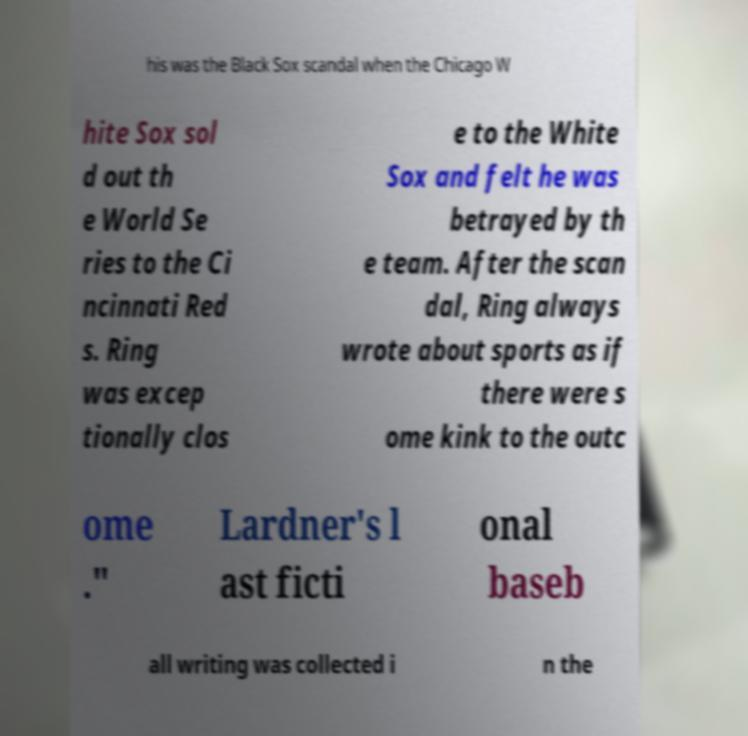There's text embedded in this image that I need extracted. Can you transcribe it verbatim? his was the Black Sox scandal when the Chicago W hite Sox sol d out th e World Se ries to the Ci ncinnati Red s. Ring was excep tionally clos e to the White Sox and felt he was betrayed by th e team. After the scan dal, Ring always wrote about sports as if there were s ome kink to the outc ome ." Lardner's l ast ficti onal baseb all writing was collected i n the 